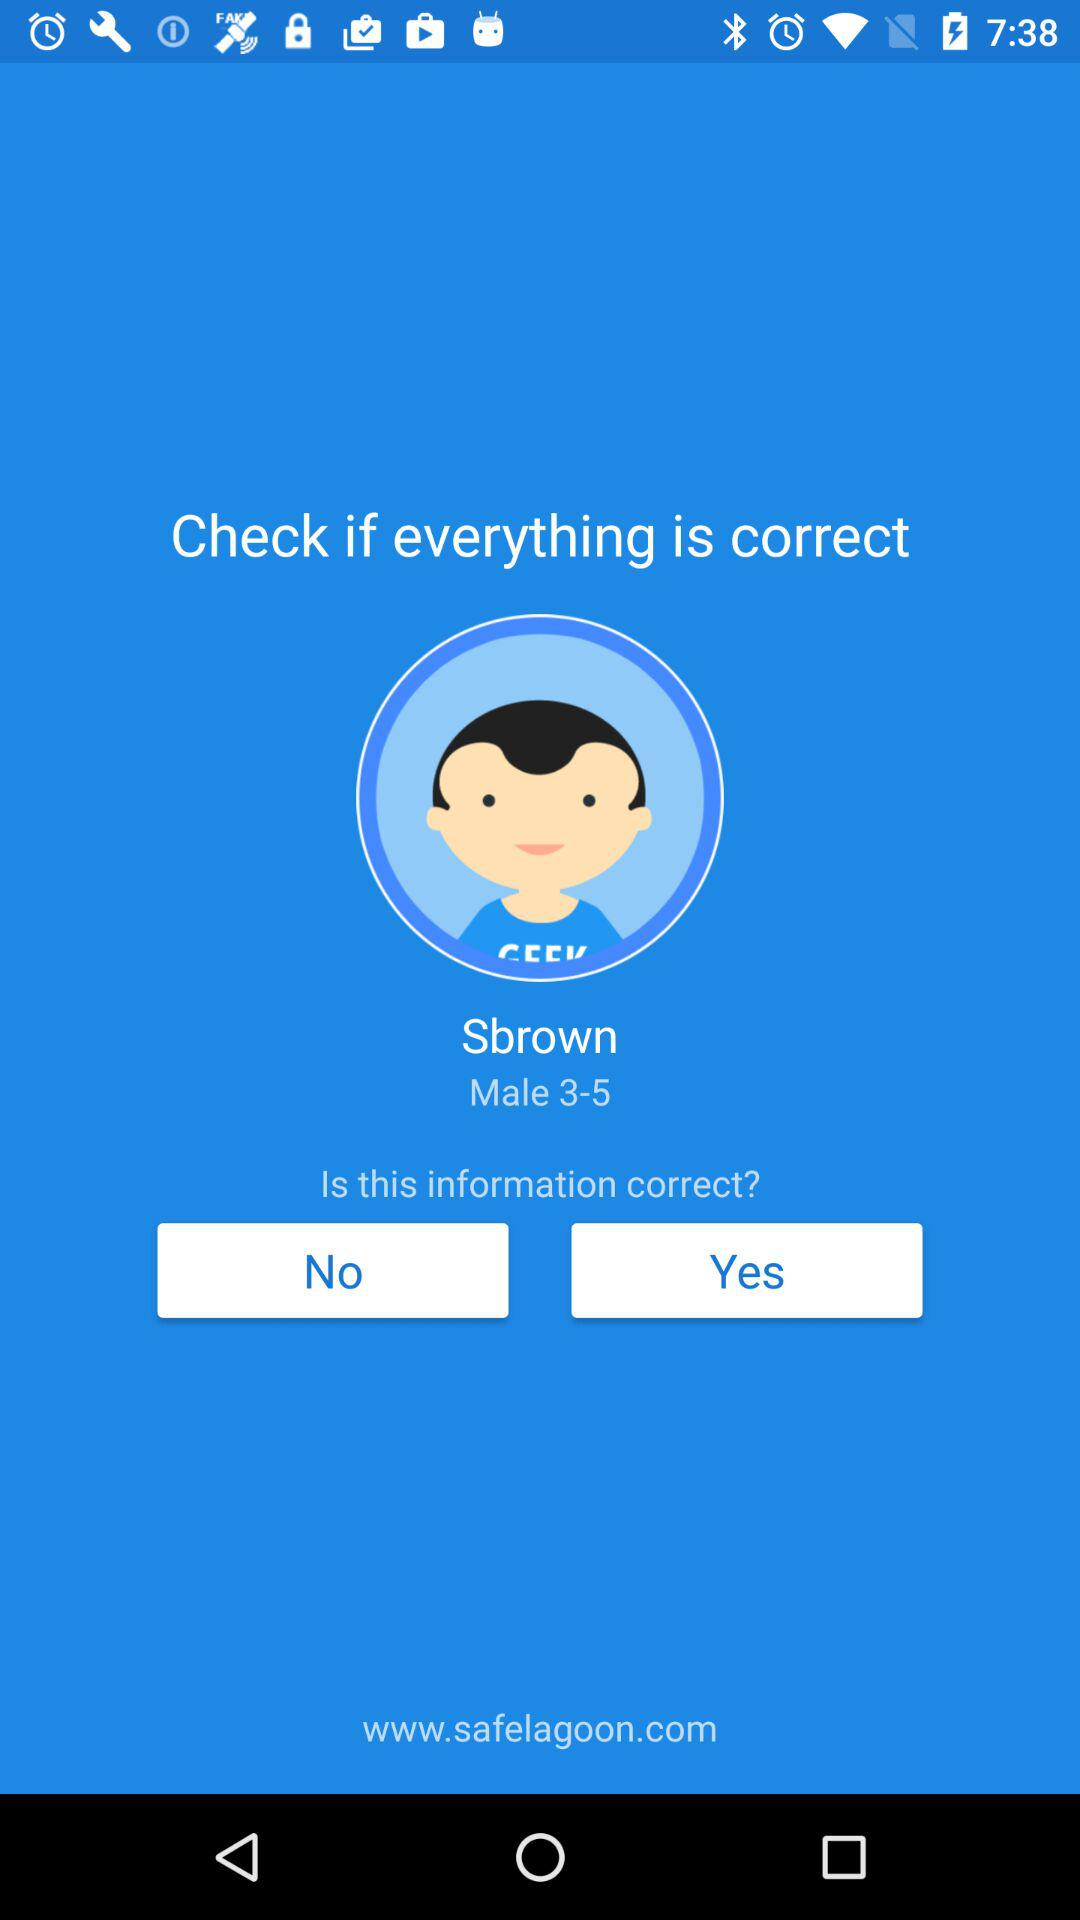What is the age range of Sbrown? The age range is 3-5. 